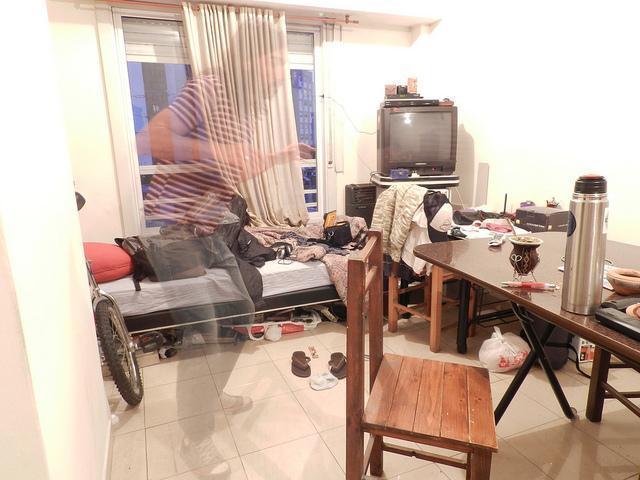The way the person appears makes them look like what type of being?
Select the accurate response from the four choices given to answer the question.
Options: Ghost, werewolf, vampire, wendigo. Ghost. 